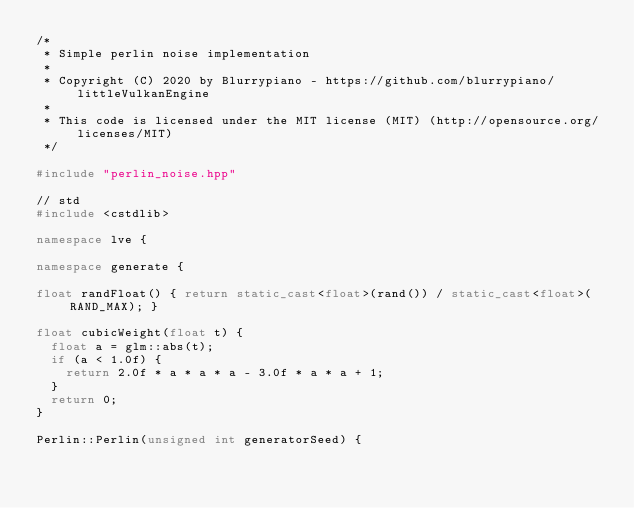<code> <loc_0><loc_0><loc_500><loc_500><_C++_>/*
 * Simple perlin noise implementation
 *
 * Copyright (C) 2020 by Blurrypiano - https://github.com/blurrypiano/littleVulkanEngine
 *
 * This code is licensed under the MIT license (MIT) (http://opensource.org/licenses/MIT)
 */

#include "perlin_noise.hpp"

// std
#include <cstdlib>

namespace lve {

namespace generate {

float randFloat() { return static_cast<float>(rand()) / static_cast<float>(RAND_MAX); }

float cubicWeight(float t) {
  float a = glm::abs(t);
  if (a < 1.0f) {
    return 2.0f * a * a * a - 3.0f * a * a + 1;
  }
  return 0;
}

Perlin::Perlin(unsigned int generatorSeed) {</code> 